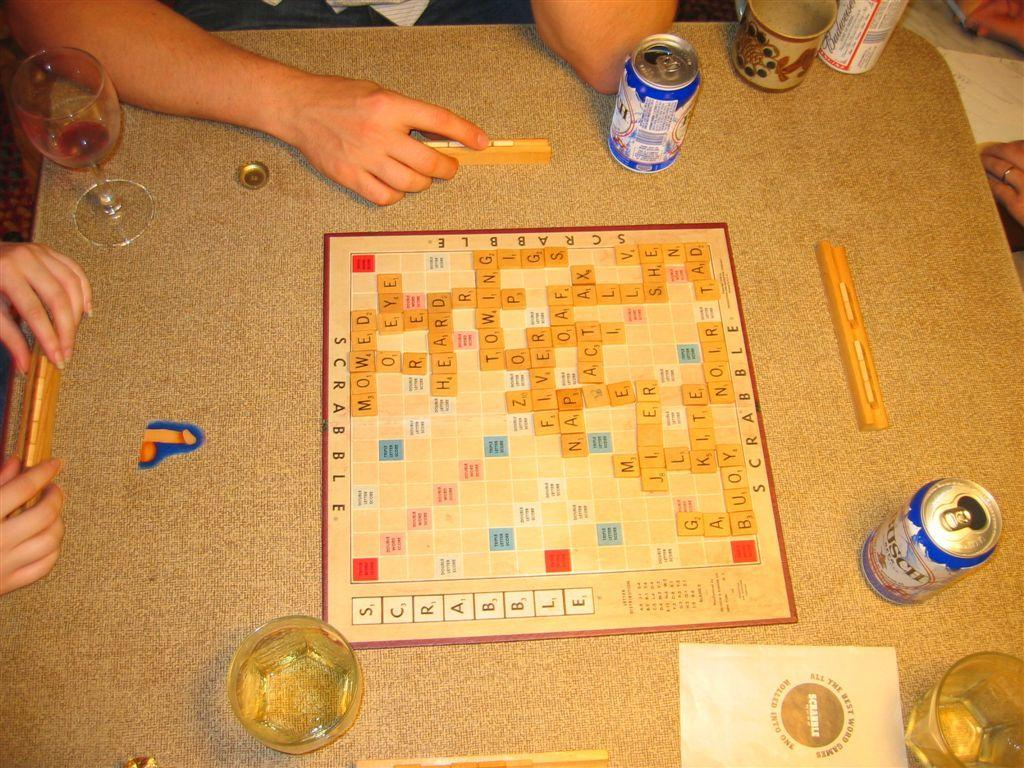What is the main piece of furniture in the image? There is a table in the image. What can be seen on the table? There are glasses of drinks on the table. Are there any other objects on the table besides the glasses of drinks? Yes, there are other objects on the table. What are the persons in the image doing with the objects on the table? The persons are holding an object placed on the table. What type of record can be heard playing on the sidewalk in the image? There is no record or sidewalk present in the image; it only features a table with glasses of drinks and other objects, along with persons holding an object. 